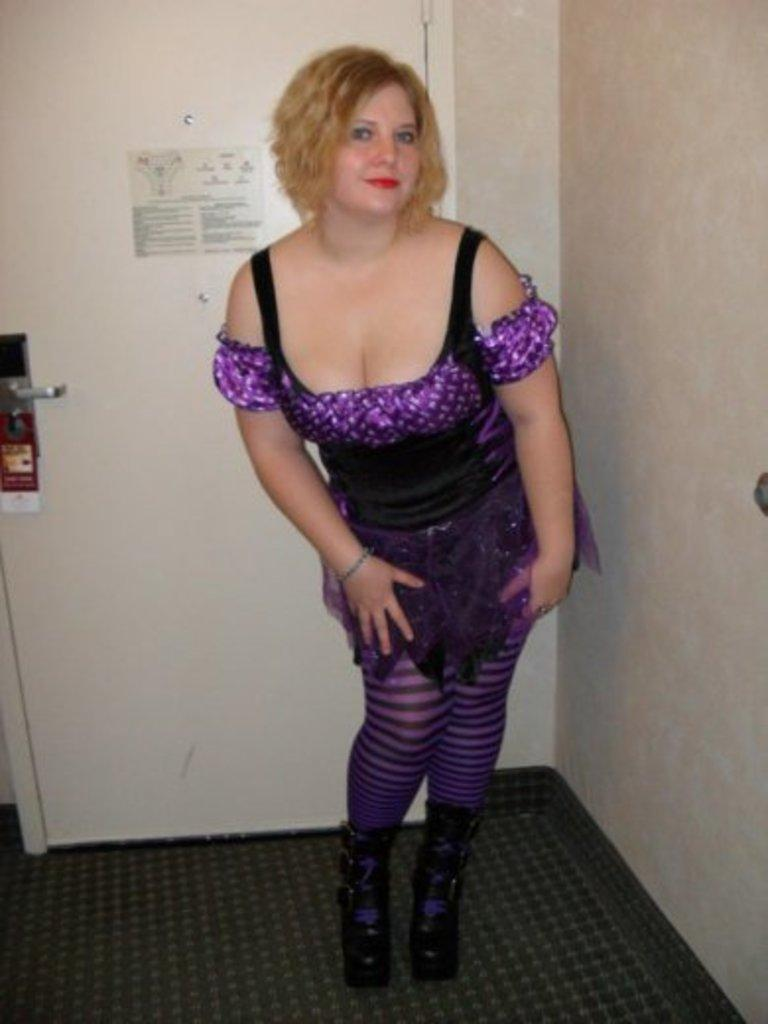What is the main subject of the image? There is a woman standing in the center of the image. What is the woman's expression in the image? The woman is smiling in the image. What can be seen in the background of the image? There is a wall, a door, and posters in the background of the image. What type of heat can be felt coming from the posters in the image? There is no indication of heat or temperature in the image, and the posters do not emit any heat. 